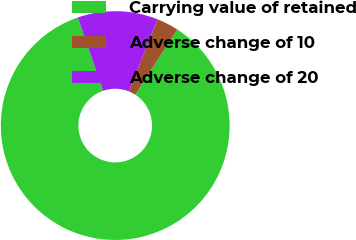Convert chart. <chart><loc_0><loc_0><loc_500><loc_500><pie_chart><fcel>Carrying value of retained<fcel>Adverse change of 10<fcel>Adverse change of 20<nl><fcel>85.56%<fcel>3.1%<fcel>11.34%<nl></chart> 